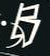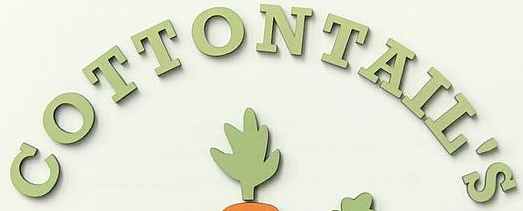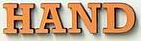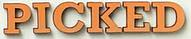What text is displayed in these images sequentially, separated by a semicolon? B; COTTONTAIL'S; HAND; PICKED 